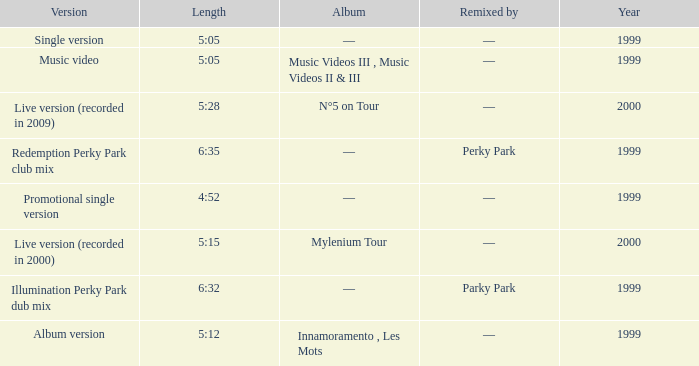What album is 5:15 long Live version (recorded in 2000). 